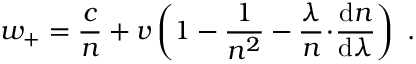<formula> <loc_0><loc_0><loc_500><loc_500>w _ { + } = { \frac { c } { n } } + v \left ( 1 - { \frac { 1 } { n ^ { 2 } } } - { \frac { \lambda } { n } } \, \cdot \, { \frac { d n } { d \lambda } } \right ) \ .</formula> 